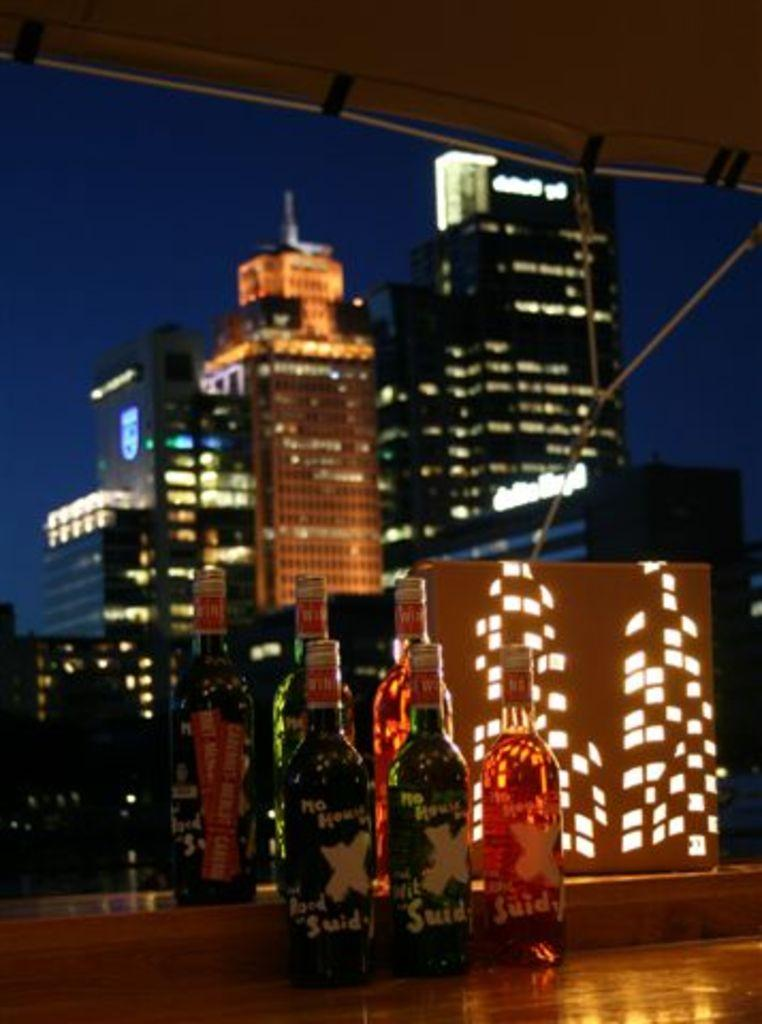<image>
Present a compact description of the photo's key features. A view of the city behind bottles of alcohol with the letter X on the front of them. 